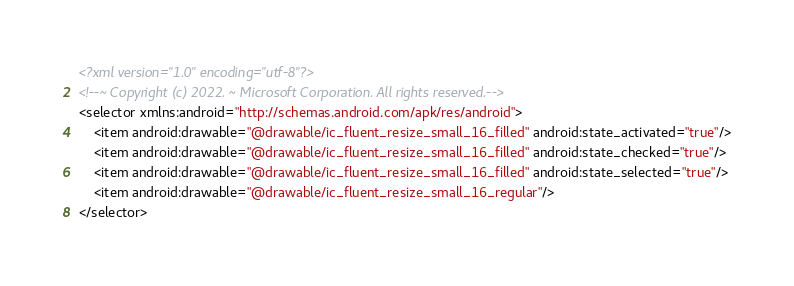<code> <loc_0><loc_0><loc_500><loc_500><_XML_><?xml version="1.0" encoding="utf-8"?>
<!--~ Copyright (c) 2022. ~ Microsoft Corporation. All rights reserved.-->
<selector xmlns:android="http://schemas.android.com/apk/res/android">
    <item android:drawable="@drawable/ic_fluent_resize_small_16_filled" android:state_activated="true"/>
    <item android:drawable="@drawable/ic_fluent_resize_small_16_filled" android:state_checked="true"/>
    <item android:drawable="@drawable/ic_fluent_resize_small_16_filled" android:state_selected="true"/>
    <item android:drawable="@drawable/ic_fluent_resize_small_16_regular"/>
</selector>
</code> 